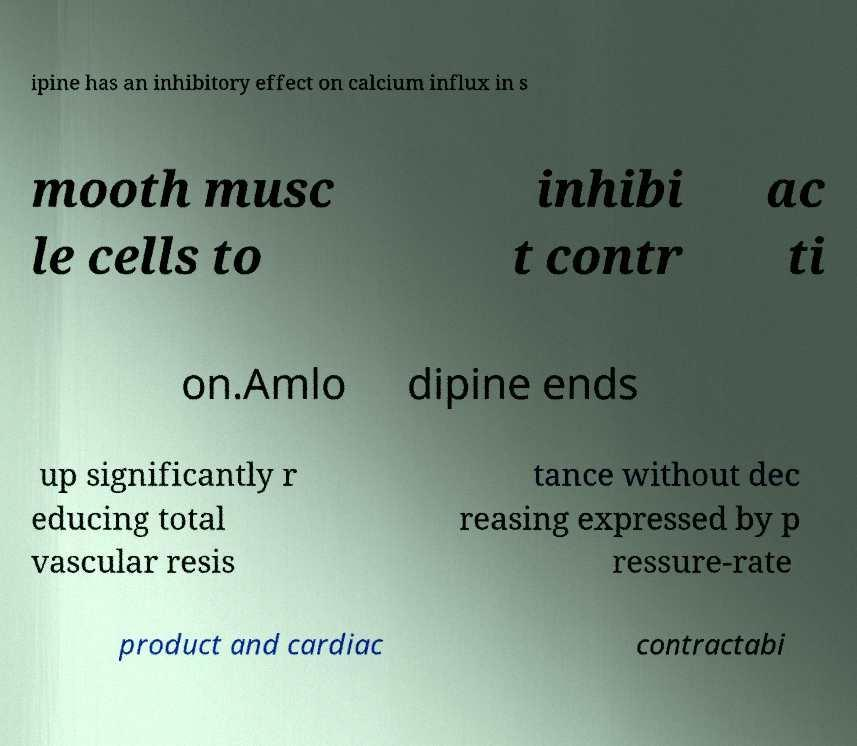Please read and relay the text visible in this image. What does it say? ipine has an inhibitory effect on calcium influx in s mooth musc le cells to inhibi t contr ac ti on.Amlo dipine ends up significantly r educing total vascular resis tance without dec reasing expressed by p ressure-rate product and cardiac contractabi 